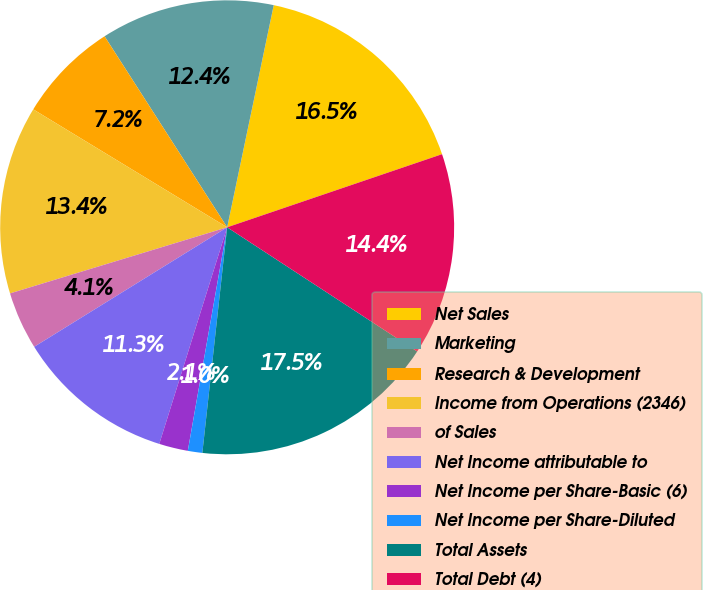Convert chart to OTSL. <chart><loc_0><loc_0><loc_500><loc_500><pie_chart><fcel>Net Sales<fcel>Marketing<fcel>Research & Development<fcel>Income from Operations (2346)<fcel>of Sales<fcel>Net Income attributable to<fcel>Net Income per Share-Basic (6)<fcel>Net Income per Share-Diluted<fcel>Total Assets<fcel>Total Debt (4)<nl><fcel>16.49%<fcel>12.37%<fcel>7.22%<fcel>13.4%<fcel>4.12%<fcel>11.34%<fcel>2.06%<fcel>1.03%<fcel>17.53%<fcel>14.43%<nl></chart> 